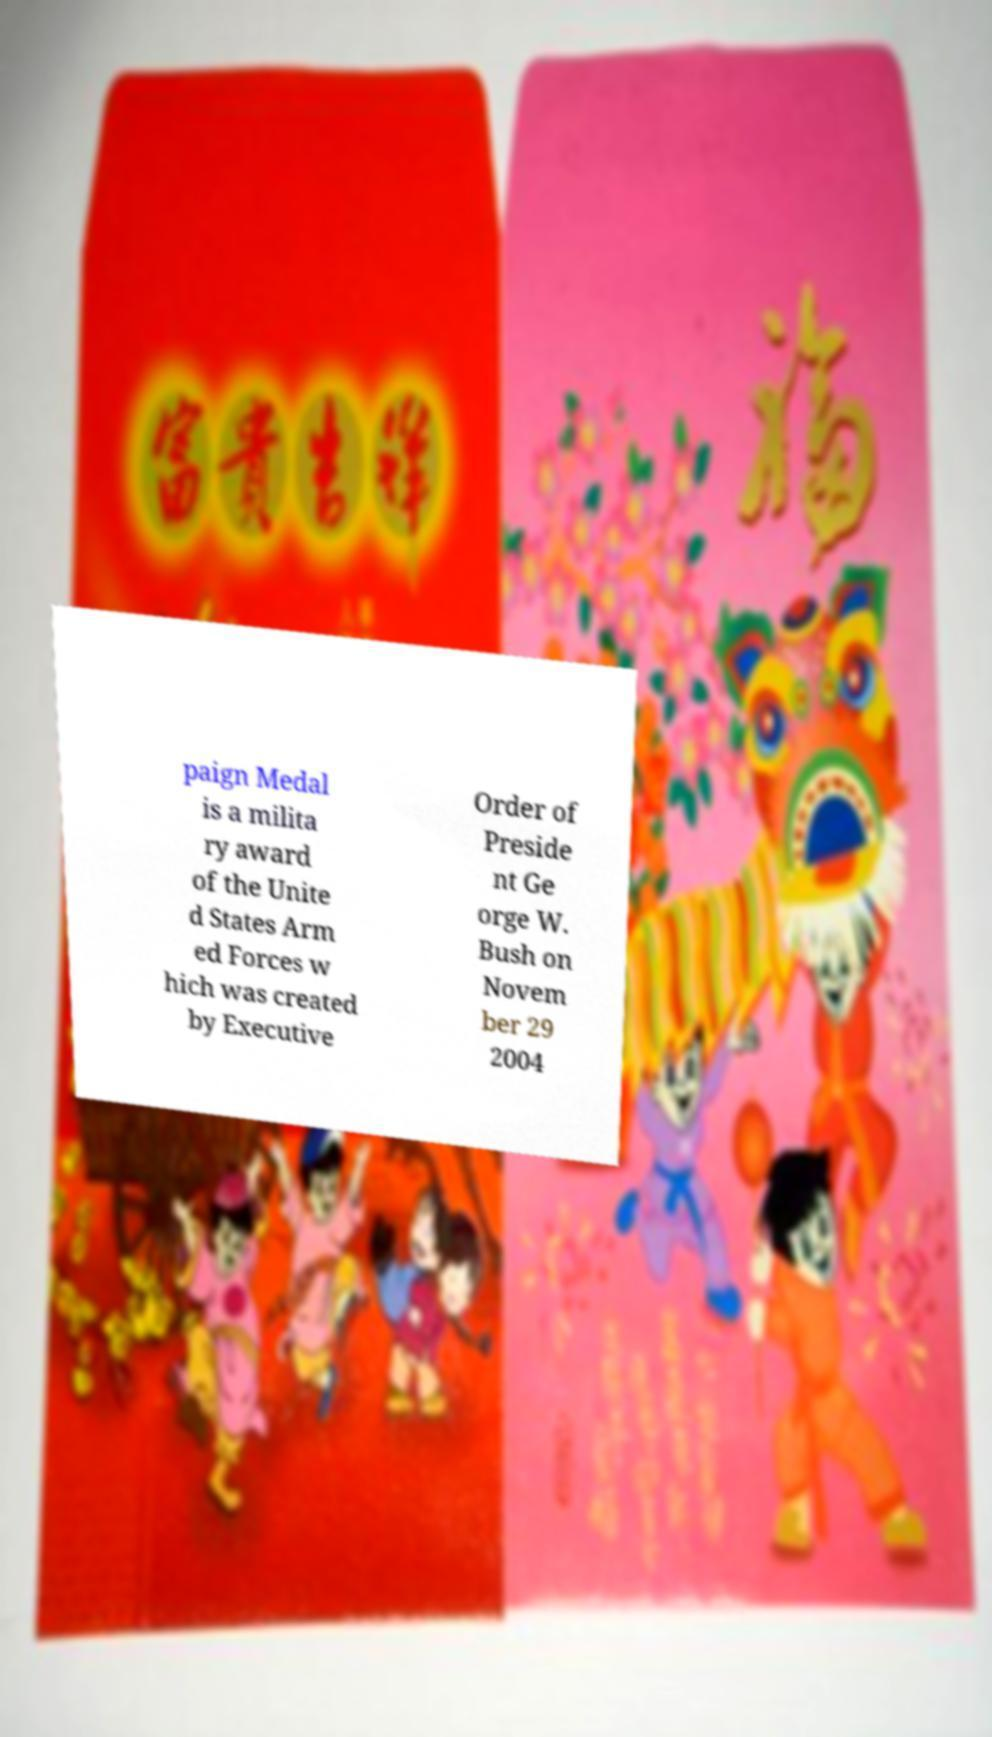Can you accurately transcribe the text from the provided image for me? paign Medal is a milita ry award of the Unite d States Arm ed Forces w hich was created by Executive Order of Preside nt Ge orge W. Bush on Novem ber 29 2004 